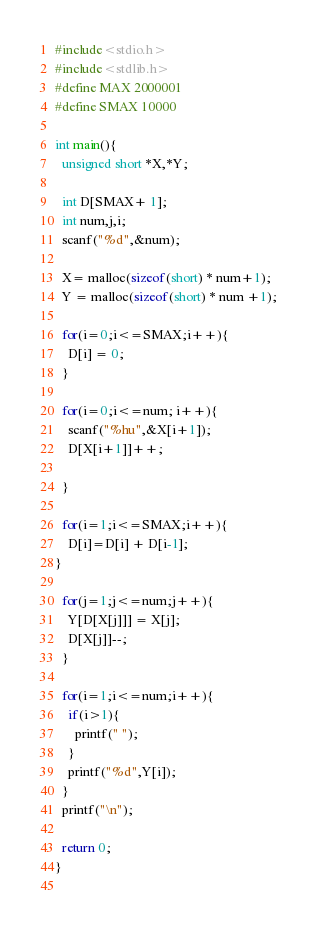Convert code to text. <code><loc_0><loc_0><loc_500><loc_500><_C_>#include<stdio.h>
#include<stdlib.h>
#define MAX 2000001
#define SMAX 10000

int main(){
  unsigned short *X,*Y;

  int D[SMAX+ 1];
  int num,j,i;
  scanf("%d",&num);

  X= malloc(sizeof(short) * num+1);
  Y = malloc(sizeof(short) * num +1);

  for(i=0;i<=SMAX;i++){
    D[i] = 0;
  }

  for(i=0;i<=num; i++){
    scanf("%hu",&X[i+1]);
    D[X[i+1]]++;
    
  }

  for(i=1;i<=SMAX;i++){
    D[i]=D[i] + D[i-1];
}

  for(j=1;j<=num;j++){
    Y[D[X[j]]] = X[j];
    D[X[j]]--;
  }

  for(i=1;i<=num;i++){
    if(i>1){
      printf(" ");
    }
    printf("%d",Y[i]);
  }
  printf("\n");

  return 0;
}
  

</code> 